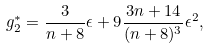<formula> <loc_0><loc_0><loc_500><loc_500>g ^ { * } _ { 2 } = \frac { 3 } { n + 8 } \epsilon + 9 \frac { 3 n + 1 4 } { ( n + 8 ) ^ { 3 } } \epsilon ^ { 2 } ,</formula> 